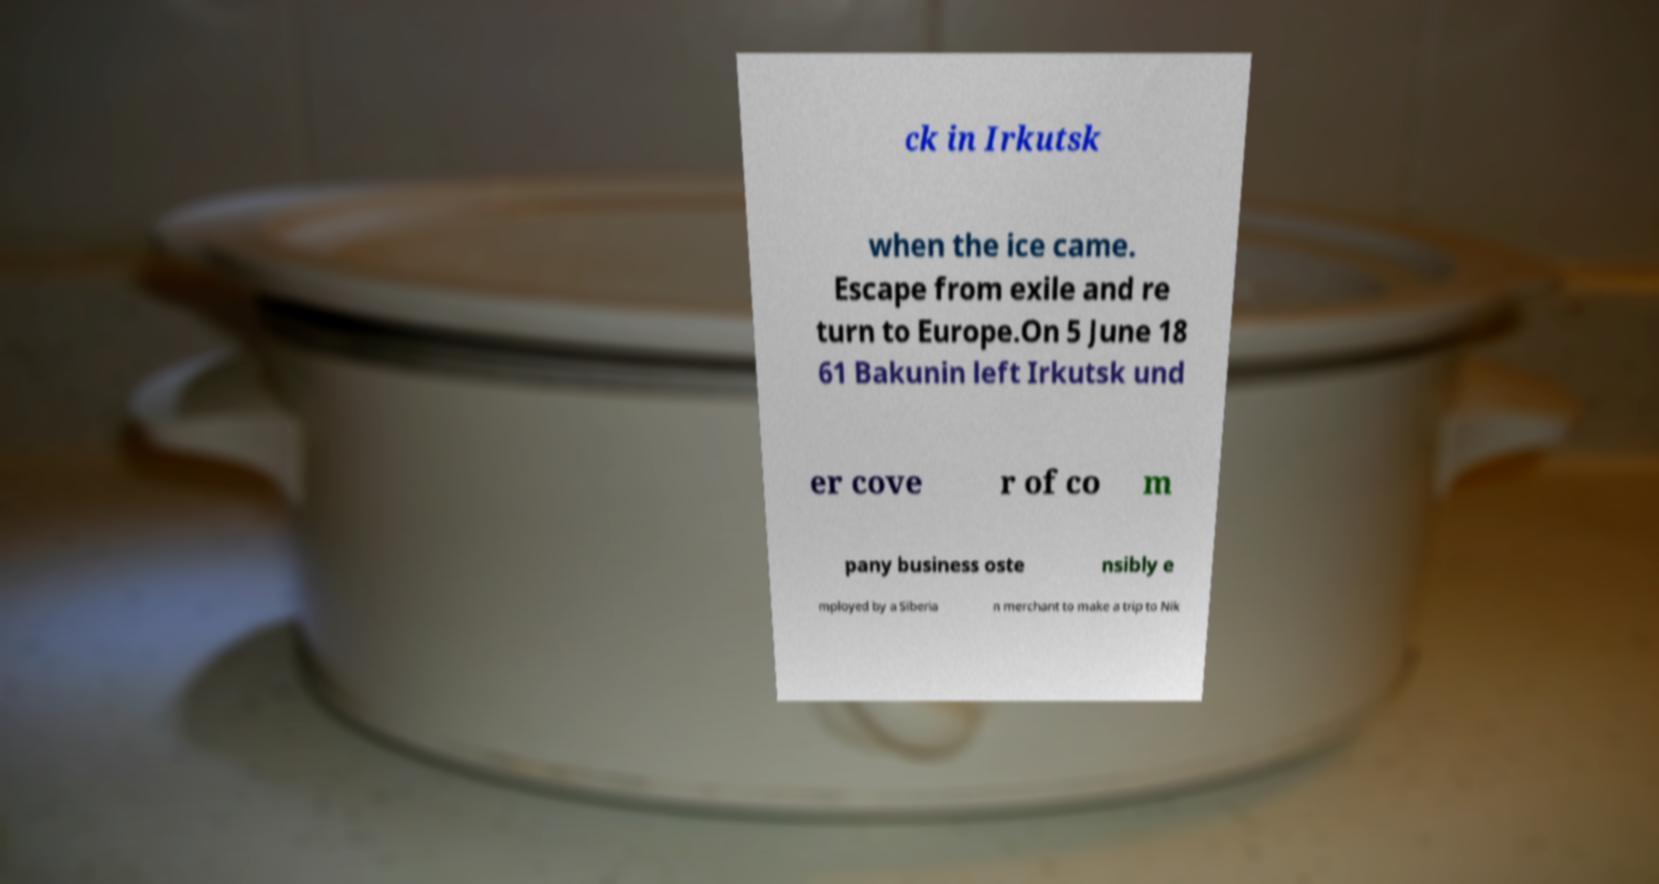Can you read and provide the text displayed in the image?This photo seems to have some interesting text. Can you extract and type it out for me? ck in Irkutsk when the ice came. Escape from exile and re turn to Europe.On 5 June 18 61 Bakunin left Irkutsk und er cove r of co m pany business oste nsibly e mployed by a Siberia n merchant to make a trip to Nik 